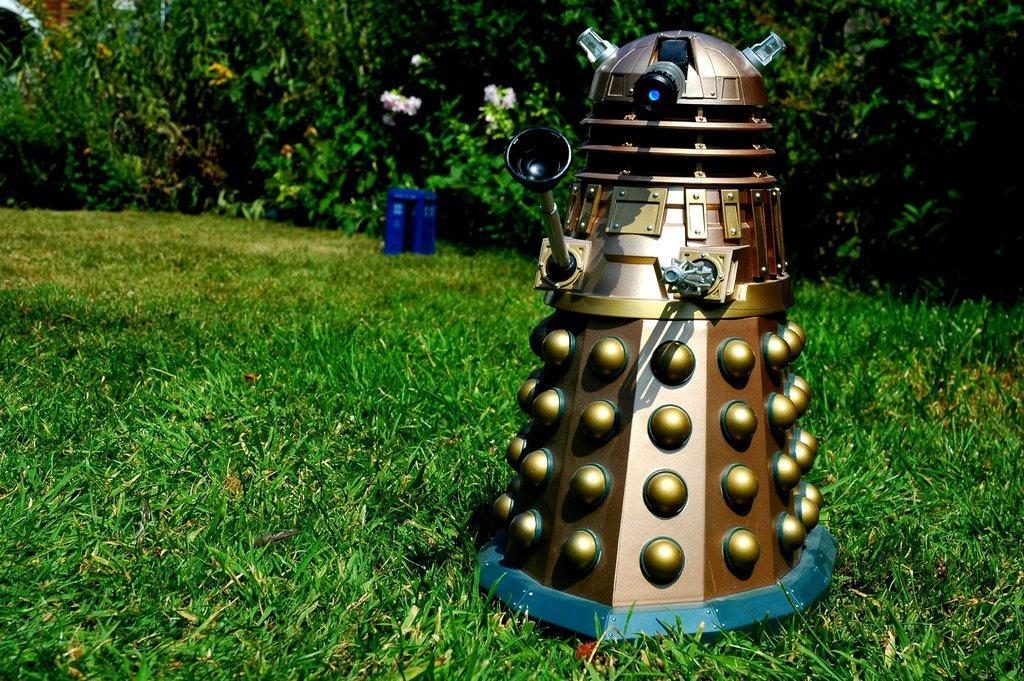In one or two sentences, can you explain what this image depicts? This is looking like a garden. On the right side, I can see a machine which is placed on the ground. At the bottom of the image I can see the grass. In the background there are many plants along with the flowers. 